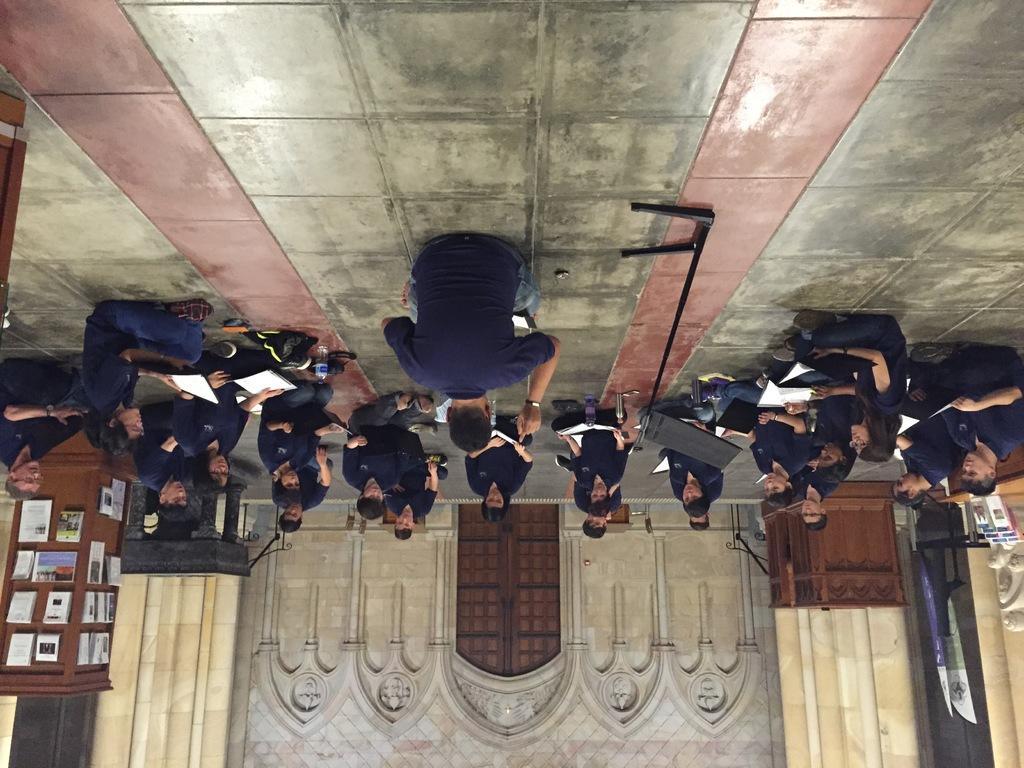Describe this image in one or two sentences. In this image there are persons wearing blue t shirt and holding papers and sitting on the ground. There is also a mike in this image. In the background there is a constructed wall with a wooden door. In the right there is a wooden structured box and also banners. In the left there are pipes attached to the wooden pillar. 